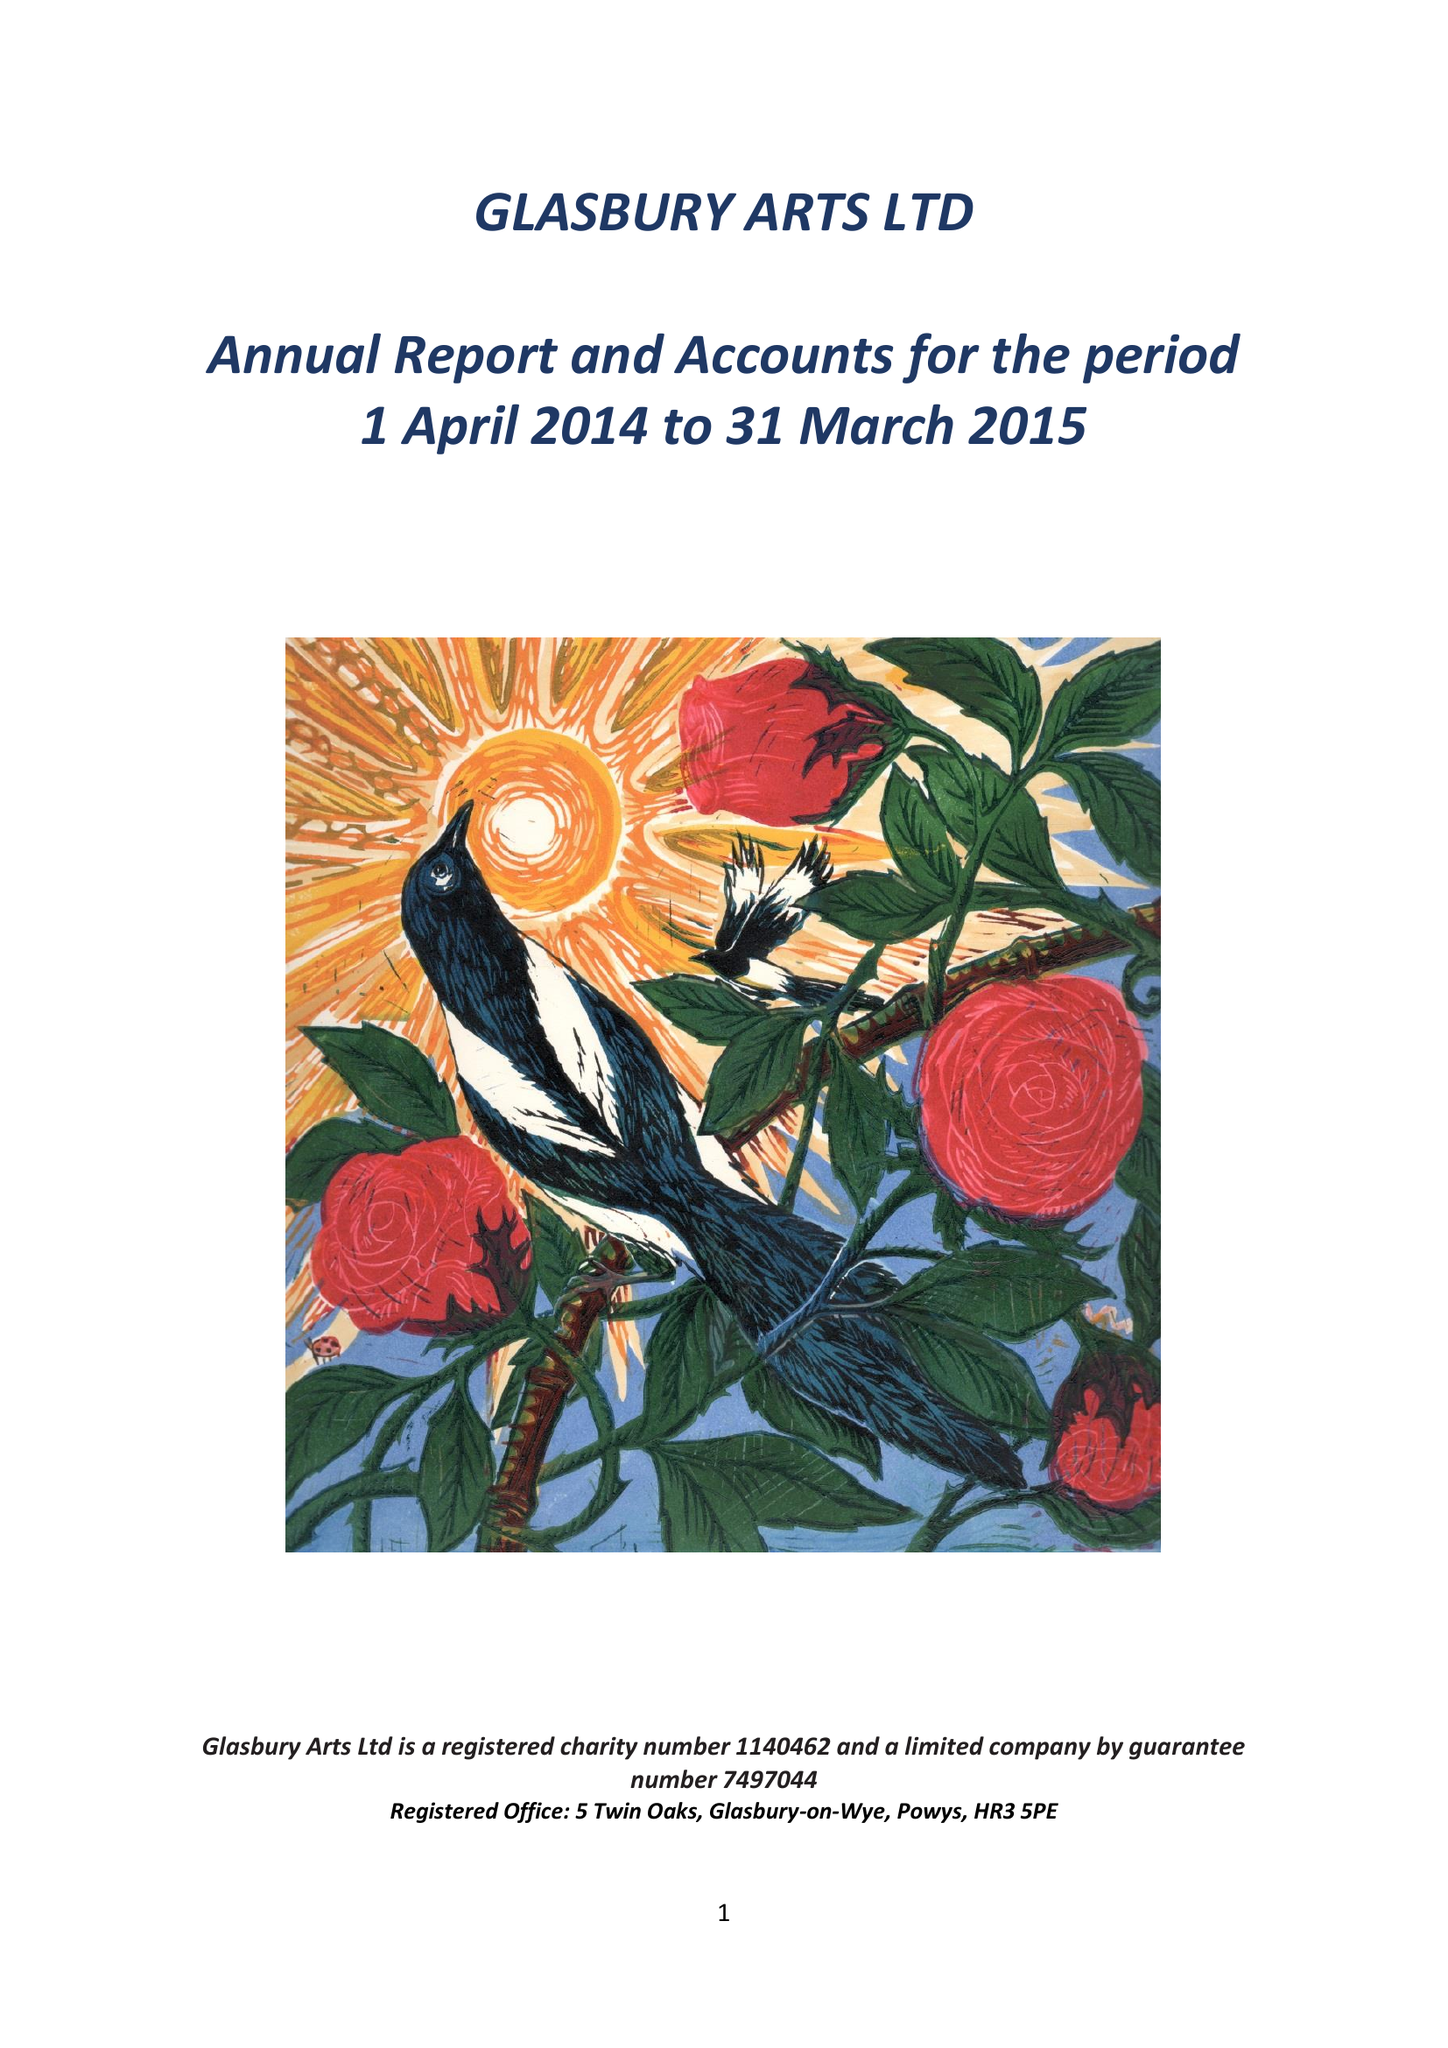What is the value for the address__postcode?
Answer the question using a single word or phrase. HR3 5PE 